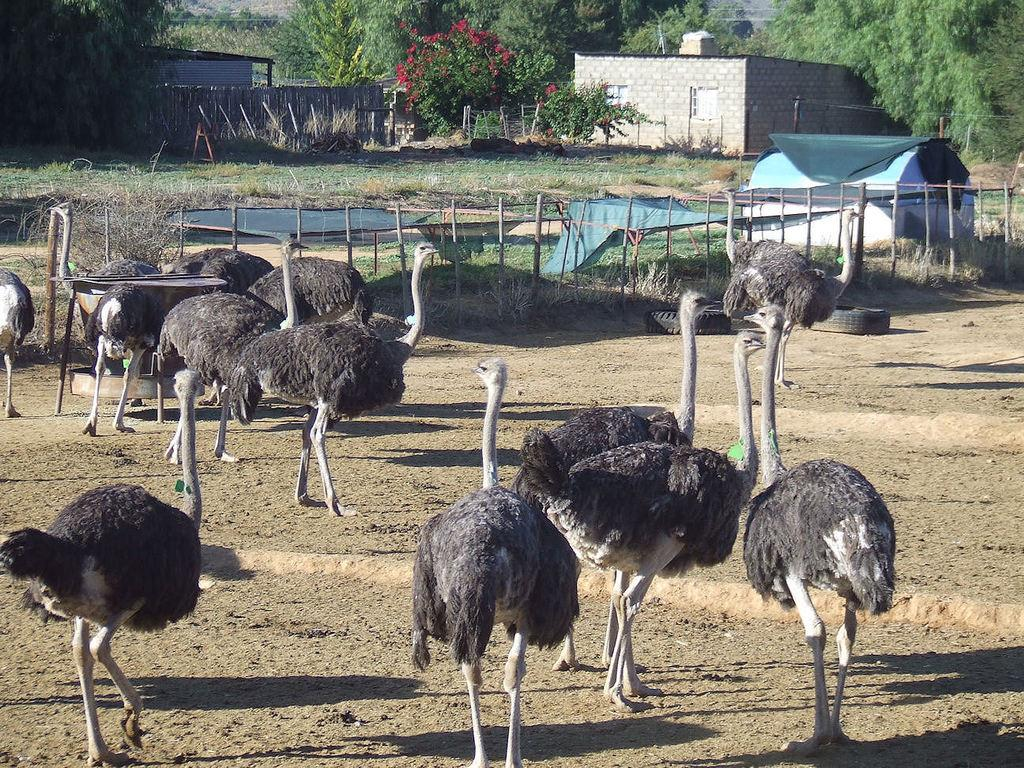What type of animals can be seen on the ground in the image? There are birds on the ground in the image. What type of structures are visible in the image? There are houses in the image. What type of vegetation is present in the image? There are trees and grass in the image. What type of objects can be seen on the ground in the image? There are wooden poles and other objects on the ground in the image. What type of barrier is present in the image? There is a wall in the image. Can you tell me how many maids are present in the image? There are no maids present in the image. What type of quiver can be seen hanging on the wall in the image? There is no quiver present in the image; there is only a wall visible. 